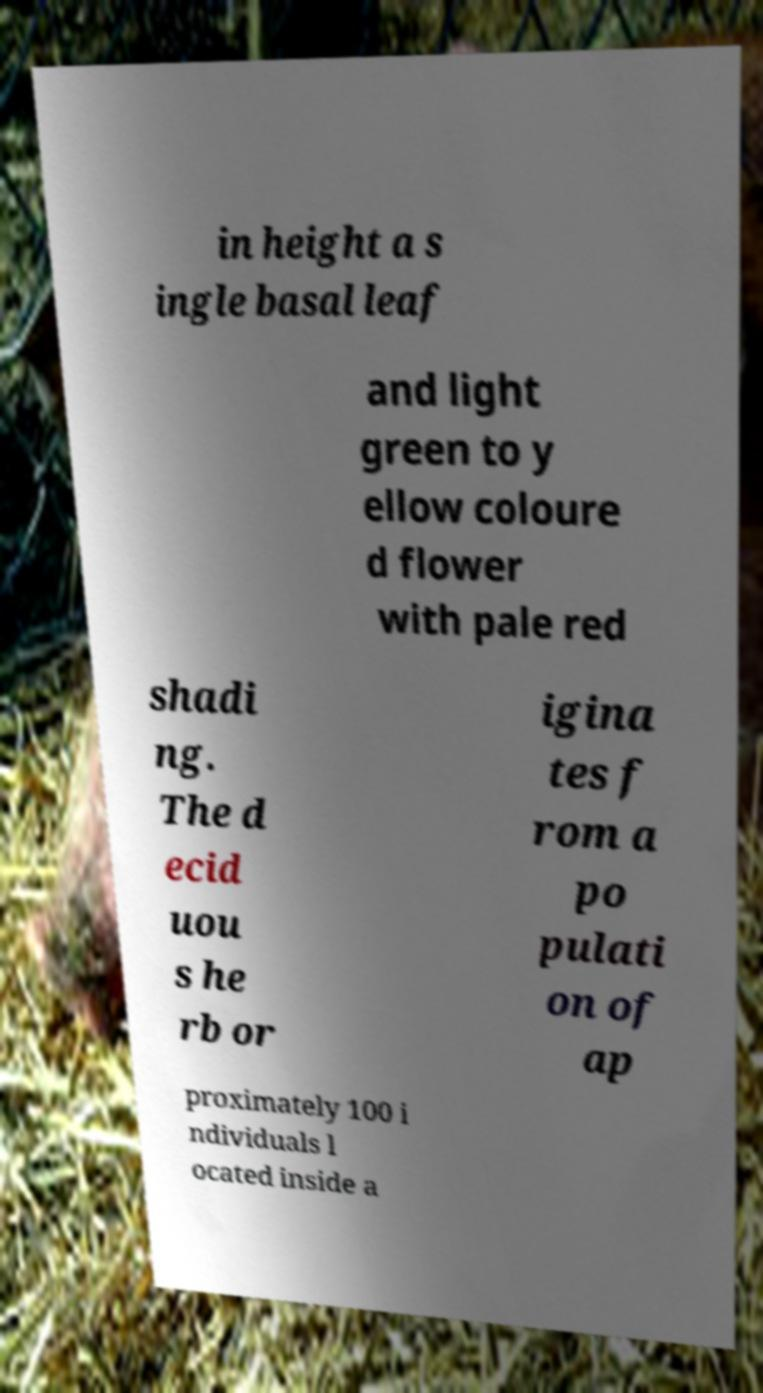For documentation purposes, I need the text within this image transcribed. Could you provide that? in height a s ingle basal leaf and light green to y ellow coloure d flower with pale red shadi ng. The d ecid uou s he rb or igina tes f rom a po pulati on of ap proximately 100 i ndividuals l ocated inside a 